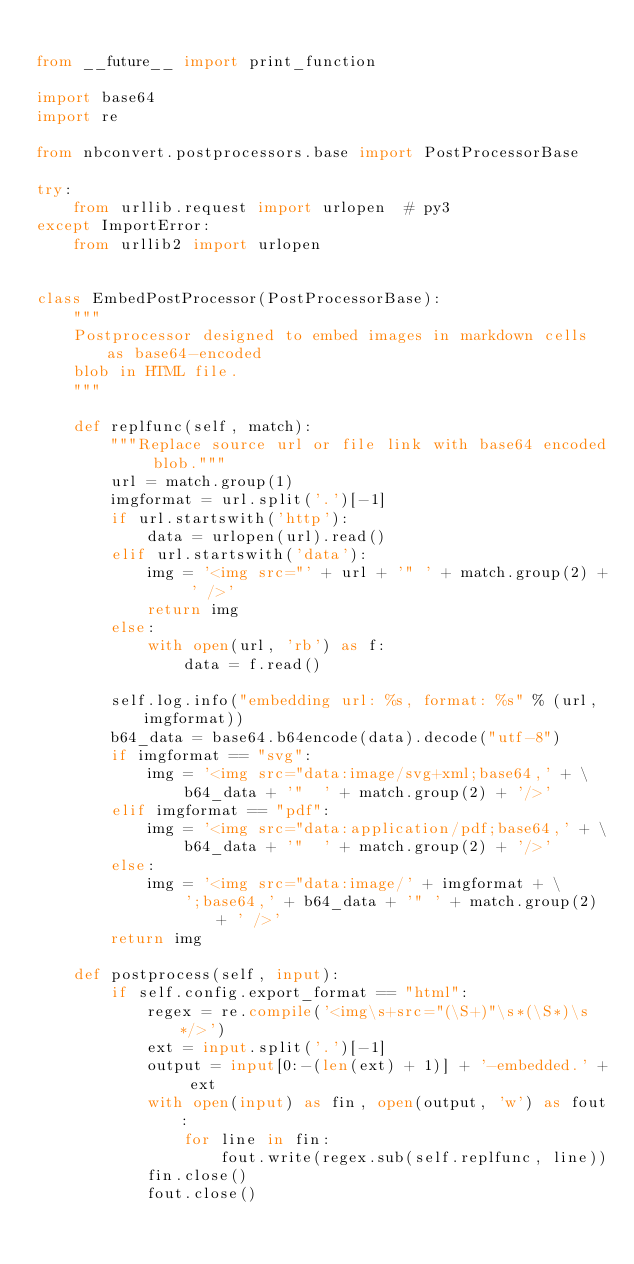<code> <loc_0><loc_0><loc_500><loc_500><_Python_>
from __future__ import print_function

import base64
import re

from nbconvert.postprocessors.base import PostProcessorBase

try:
    from urllib.request import urlopen  # py3
except ImportError:
    from urllib2 import urlopen


class EmbedPostProcessor(PostProcessorBase):
    """
    Postprocessor designed to embed images in markdown cells as base64-encoded
    blob in HTML file.
    """

    def replfunc(self, match):
        """Replace source url or file link with base64 encoded blob."""
        url = match.group(1)
        imgformat = url.split('.')[-1]
        if url.startswith('http'):
            data = urlopen(url).read()
        elif url.startswith('data'):
            img = '<img src="' + url + '" ' + match.group(2) + ' />'
            return img
        else:
            with open(url, 'rb') as f:
                data = f.read()

        self.log.info("embedding url: %s, format: %s" % (url, imgformat))
        b64_data = base64.b64encode(data).decode("utf-8")
        if imgformat == "svg":
            img = '<img src="data:image/svg+xml;base64,' + \
                b64_data + '"  ' + match.group(2) + '/>'
        elif imgformat == "pdf":
            img = '<img src="data:application/pdf;base64,' + \
                b64_data + '"  ' + match.group(2) + '/>'
        else:
            img = '<img src="data:image/' + imgformat + \
                ';base64,' + b64_data + '" ' + match.group(2) + ' />'
        return img

    def postprocess(self, input):
        if self.config.export_format == "html":
            regex = re.compile('<img\s+src="(\S+)"\s*(\S*)\s*/>')
            ext = input.split('.')[-1]
            output = input[0:-(len(ext) + 1)] + '-embedded.' + ext
            with open(input) as fin, open(output, 'w') as fout:
                for line in fin:
                    fout.write(regex.sub(self.replfunc, line))
            fin.close()
            fout.close()
</code> 